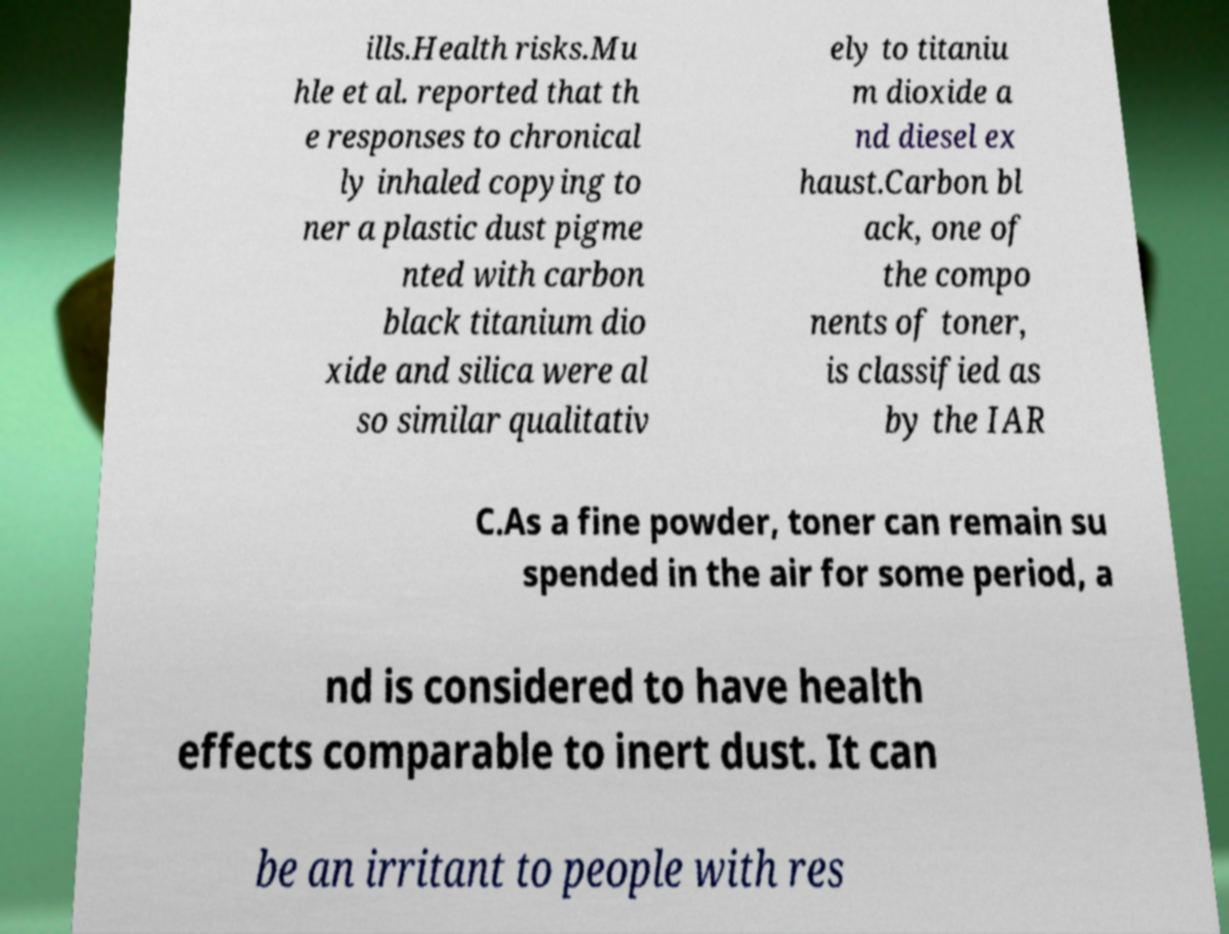Could you extract and type out the text from this image? ills.Health risks.Mu hle et al. reported that th e responses to chronical ly inhaled copying to ner a plastic dust pigme nted with carbon black titanium dio xide and silica were al so similar qualitativ ely to titaniu m dioxide a nd diesel ex haust.Carbon bl ack, one of the compo nents of toner, is classified as by the IAR C.As a fine powder, toner can remain su spended in the air for some period, a nd is considered to have health effects comparable to inert dust. It can be an irritant to people with res 